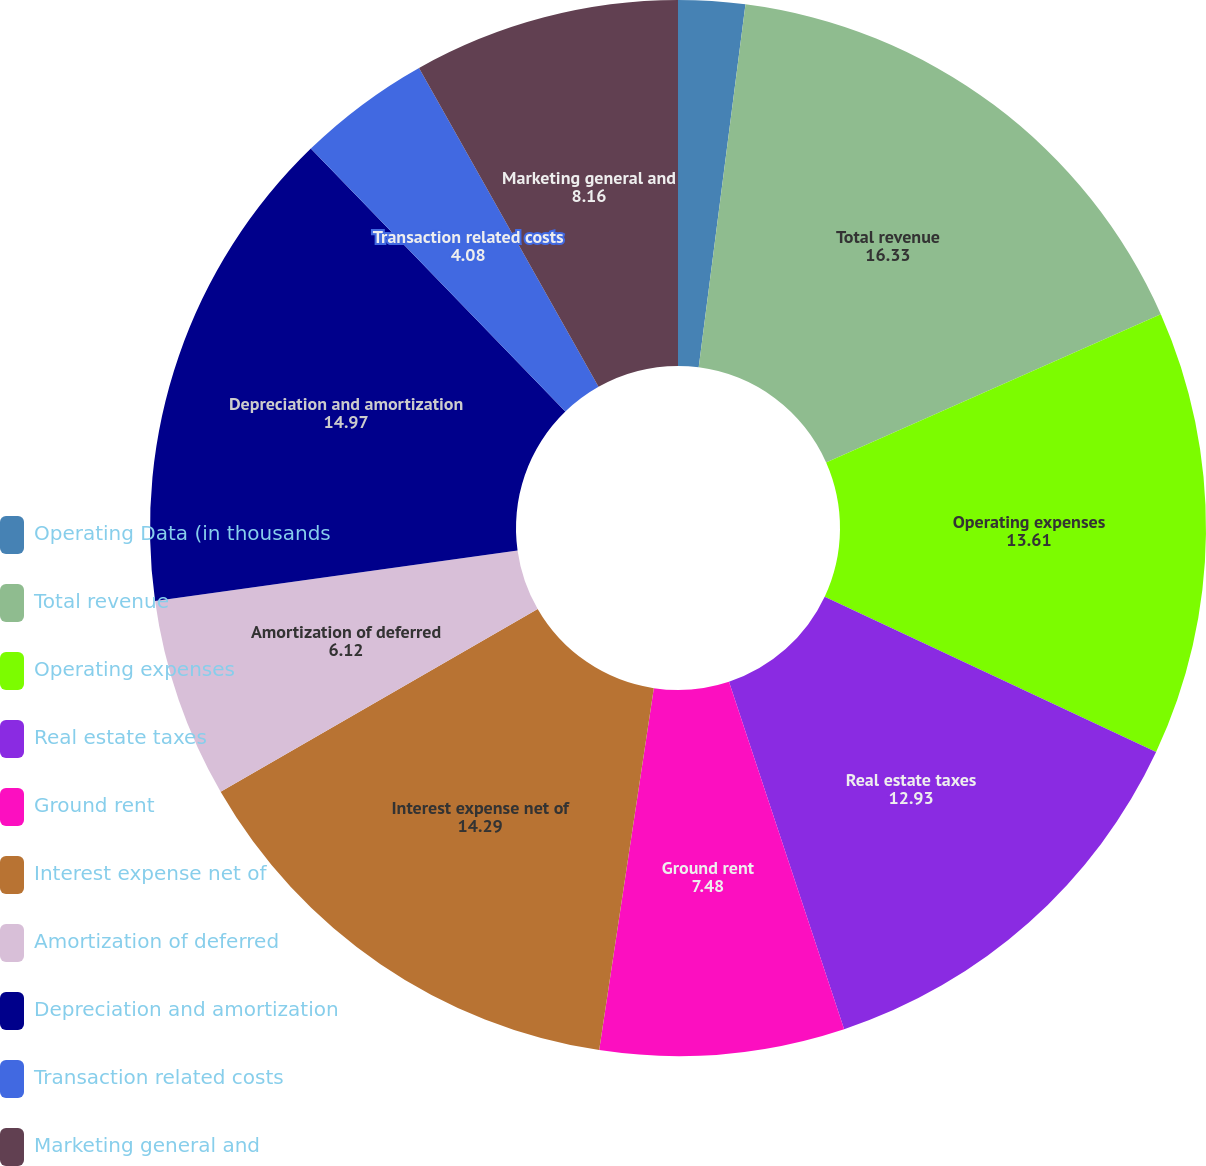Convert chart. <chart><loc_0><loc_0><loc_500><loc_500><pie_chart><fcel>Operating Data (in thousands<fcel>Total revenue<fcel>Operating expenses<fcel>Real estate taxes<fcel>Ground rent<fcel>Interest expense net of<fcel>Amortization of deferred<fcel>Depreciation and amortization<fcel>Transaction related costs<fcel>Marketing general and<nl><fcel>2.04%<fcel>16.33%<fcel>13.61%<fcel>12.93%<fcel>7.48%<fcel>14.29%<fcel>6.12%<fcel>14.97%<fcel>4.08%<fcel>8.16%<nl></chart> 